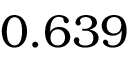Convert formula to latex. <formula><loc_0><loc_0><loc_500><loc_500>0 . 6 3 9</formula> 